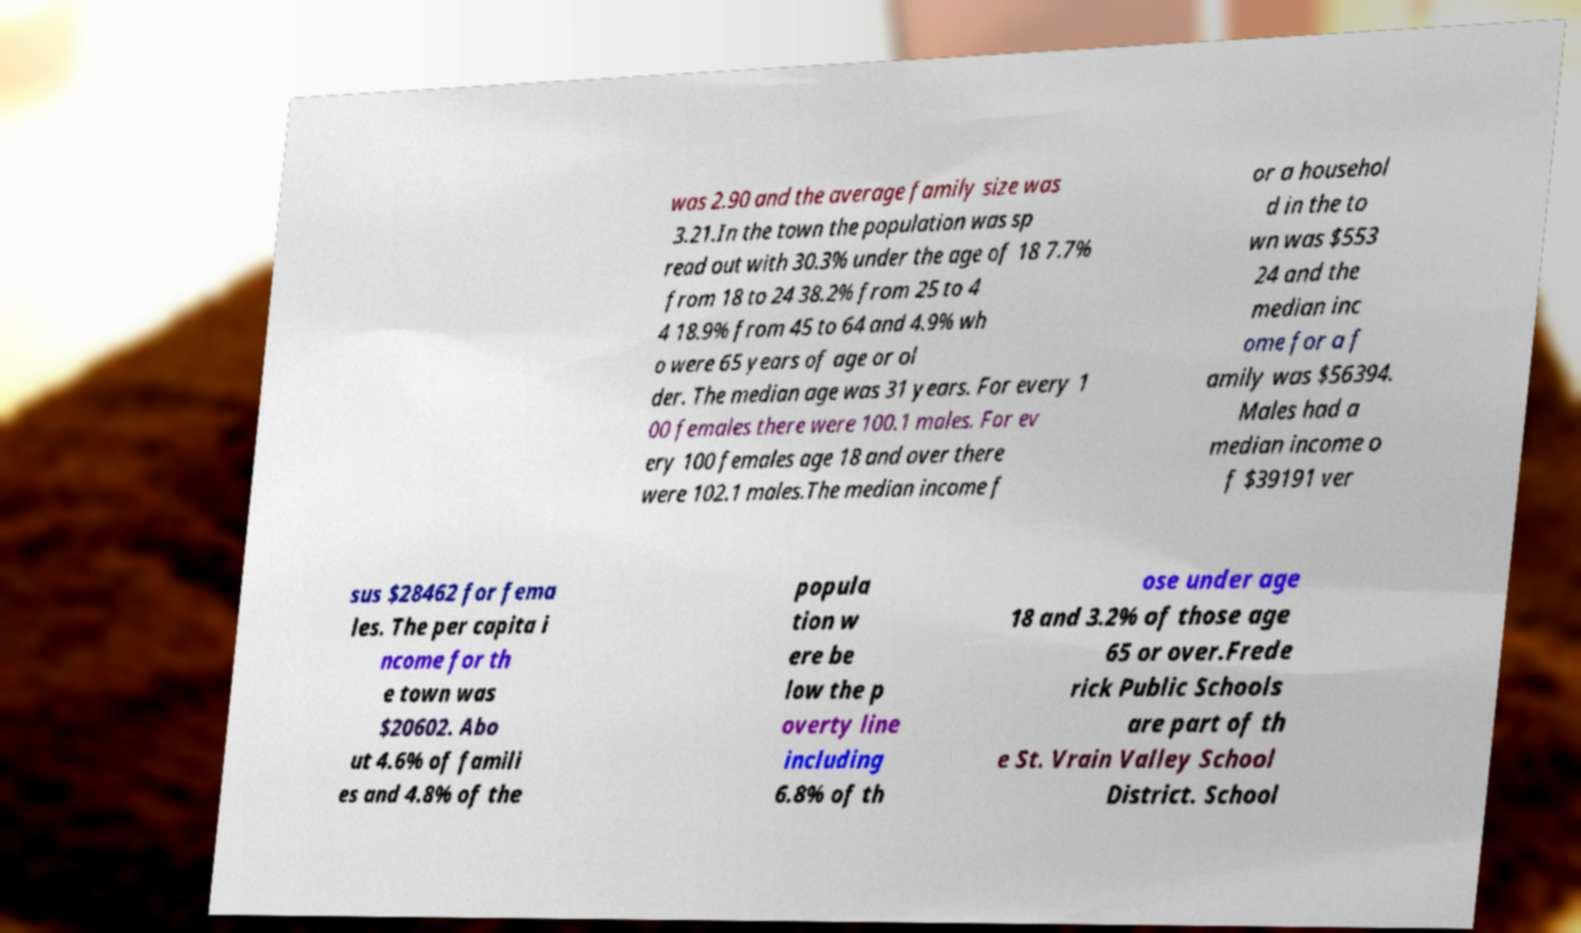Please read and relay the text visible in this image. What does it say? was 2.90 and the average family size was 3.21.In the town the population was sp read out with 30.3% under the age of 18 7.7% from 18 to 24 38.2% from 25 to 4 4 18.9% from 45 to 64 and 4.9% wh o were 65 years of age or ol der. The median age was 31 years. For every 1 00 females there were 100.1 males. For ev ery 100 females age 18 and over there were 102.1 males.The median income f or a househol d in the to wn was $553 24 and the median inc ome for a f amily was $56394. Males had a median income o f $39191 ver sus $28462 for fema les. The per capita i ncome for th e town was $20602. Abo ut 4.6% of famili es and 4.8% of the popula tion w ere be low the p overty line including 6.8% of th ose under age 18 and 3.2% of those age 65 or over.Frede rick Public Schools are part of th e St. Vrain Valley School District. School 